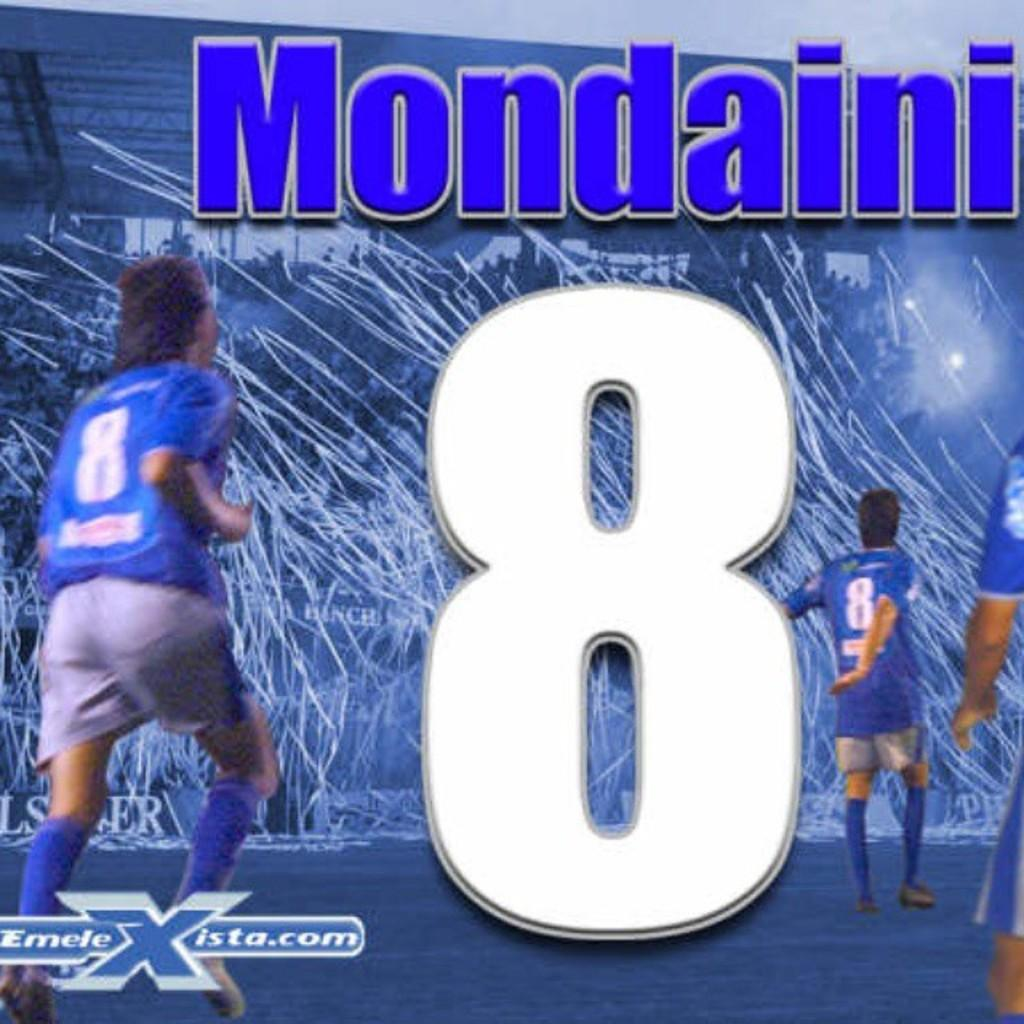<image>
Render a clear and concise summary of the photo. The blue jersey with the number 8 belongs to Mondaini. 